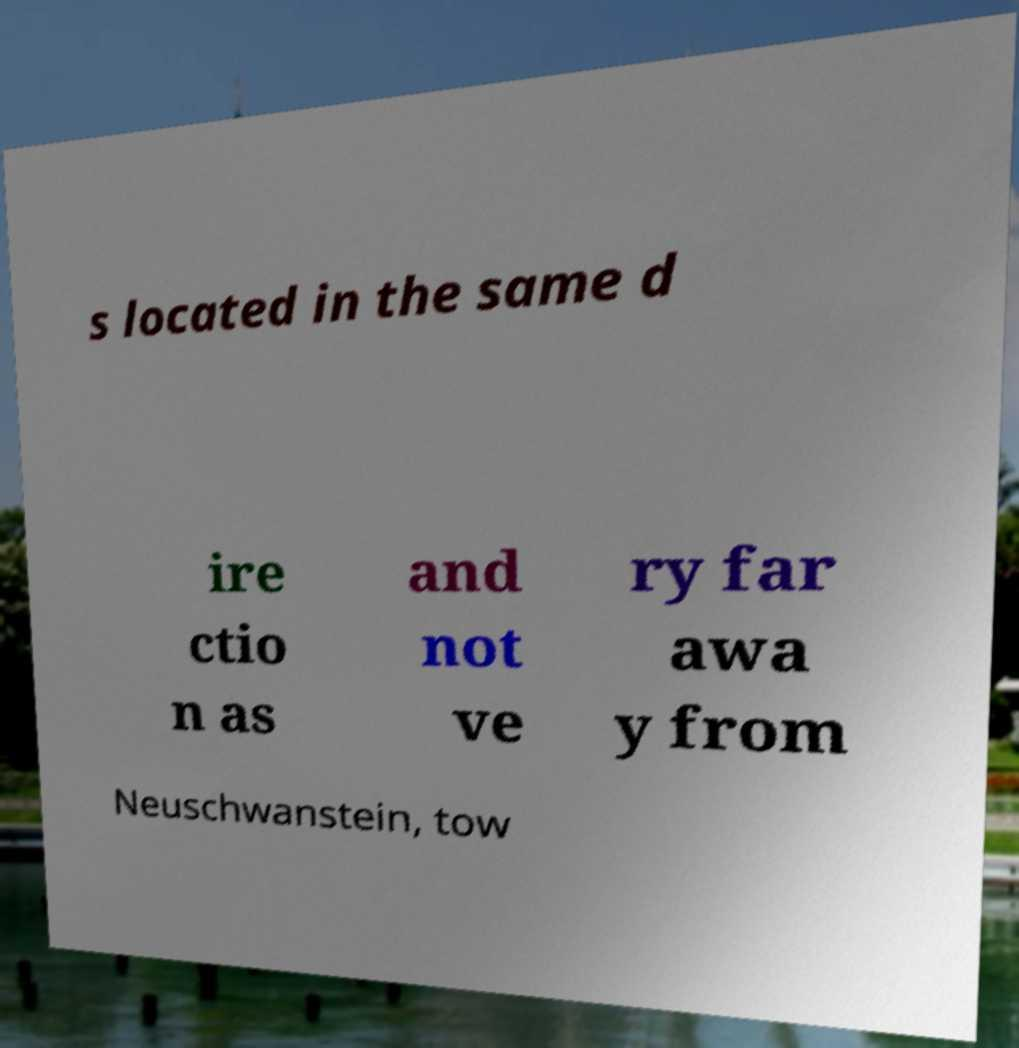Could you assist in decoding the text presented in this image and type it out clearly? s located in the same d ire ctio n as and not ve ry far awa y from Neuschwanstein, tow 